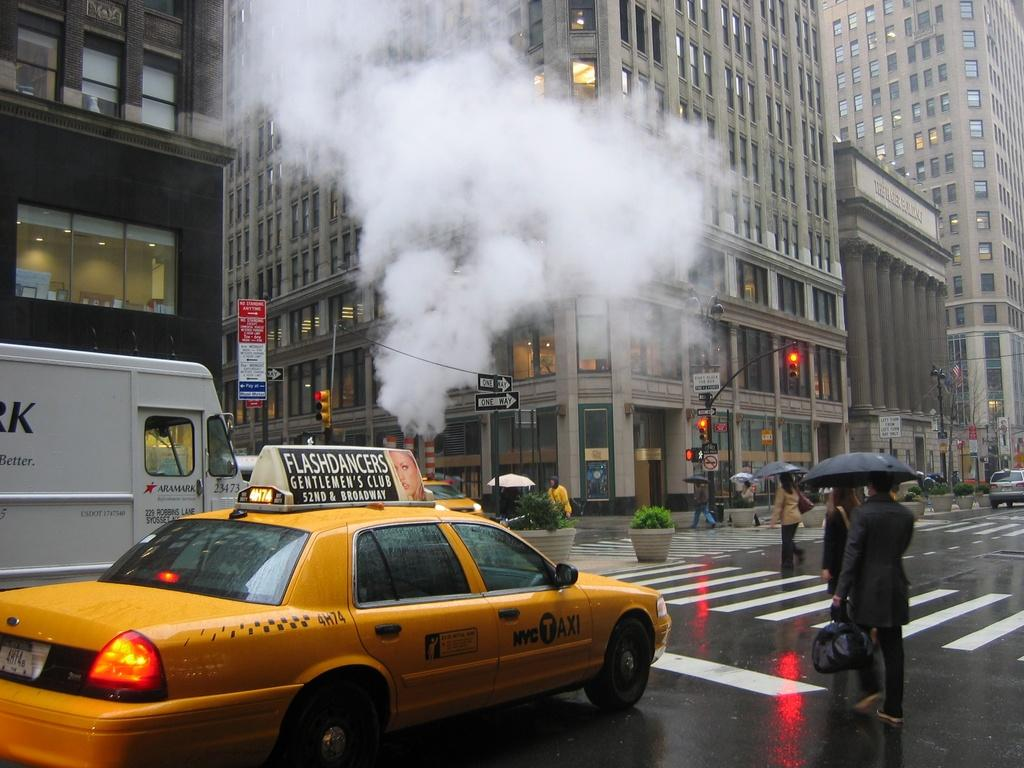<image>
Offer a succinct explanation of the picture presented. A taxi driving down a busy NY street; on the taxi there is an add for Flashdancer's gentlmens club/ 